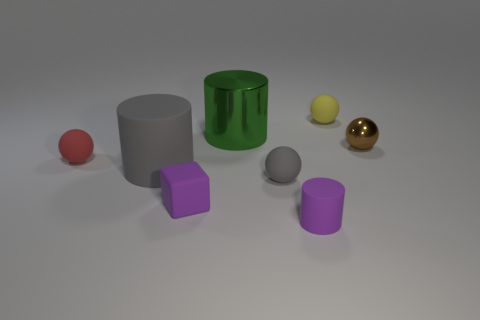How many tiny things are red shiny things or green cylinders?
Offer a very short reply. 0. What is the material of the brown object that is the same shape as the tiny gray thing?
Provide a succinct answer. Metal. The metal cylinder has what color?
Keep it short and to the point. Green. Is the color of the block the same as the tiny rubber cylinder?
Ensure brevity in your answer.  Yes. There is a small red rubber ball that is to the left of the small matte cylinder; how many matte things are in front of it?
Your response must be concise. 4. What is the size of the cylinder that is behind the purple matte cube and on the right side of the tiny purple matte block?
Ensure brevity in your answer.  Large. There is a small thing right of the yellow matte ball; what is its material?
Give a very brief answer. Metal. Are there any other metal things that have the same shape as the tiny red object?
Give a very brief answer. Yes. What number of other small matte objects have the same shape as the tiny gray object?
Your answer should be very brief. 2. Does the cylinder behind the tiny shiny ball have the same size as the gray matte thing left of the tiny block?
Offer a very short reply. Yes. 